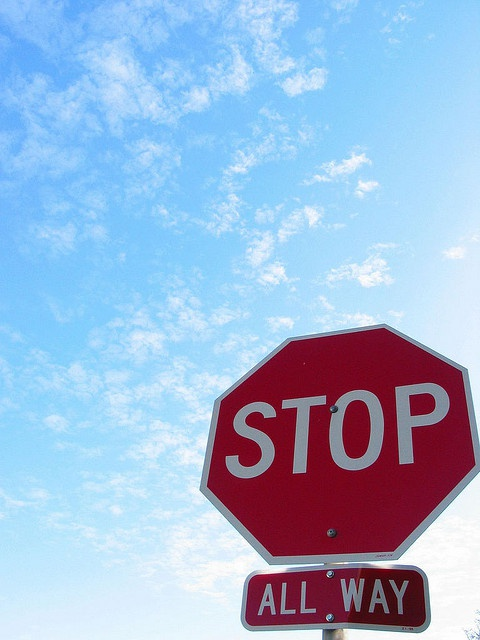Describe the objects in this image and their specific colors. I can see a stop sign in lightblue, maroon, gray, and brown tones in this image. 